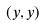Convert formula to latex. <formula><loc_0><loc_0><loc_500><loc_500>( y , y )</formula> 